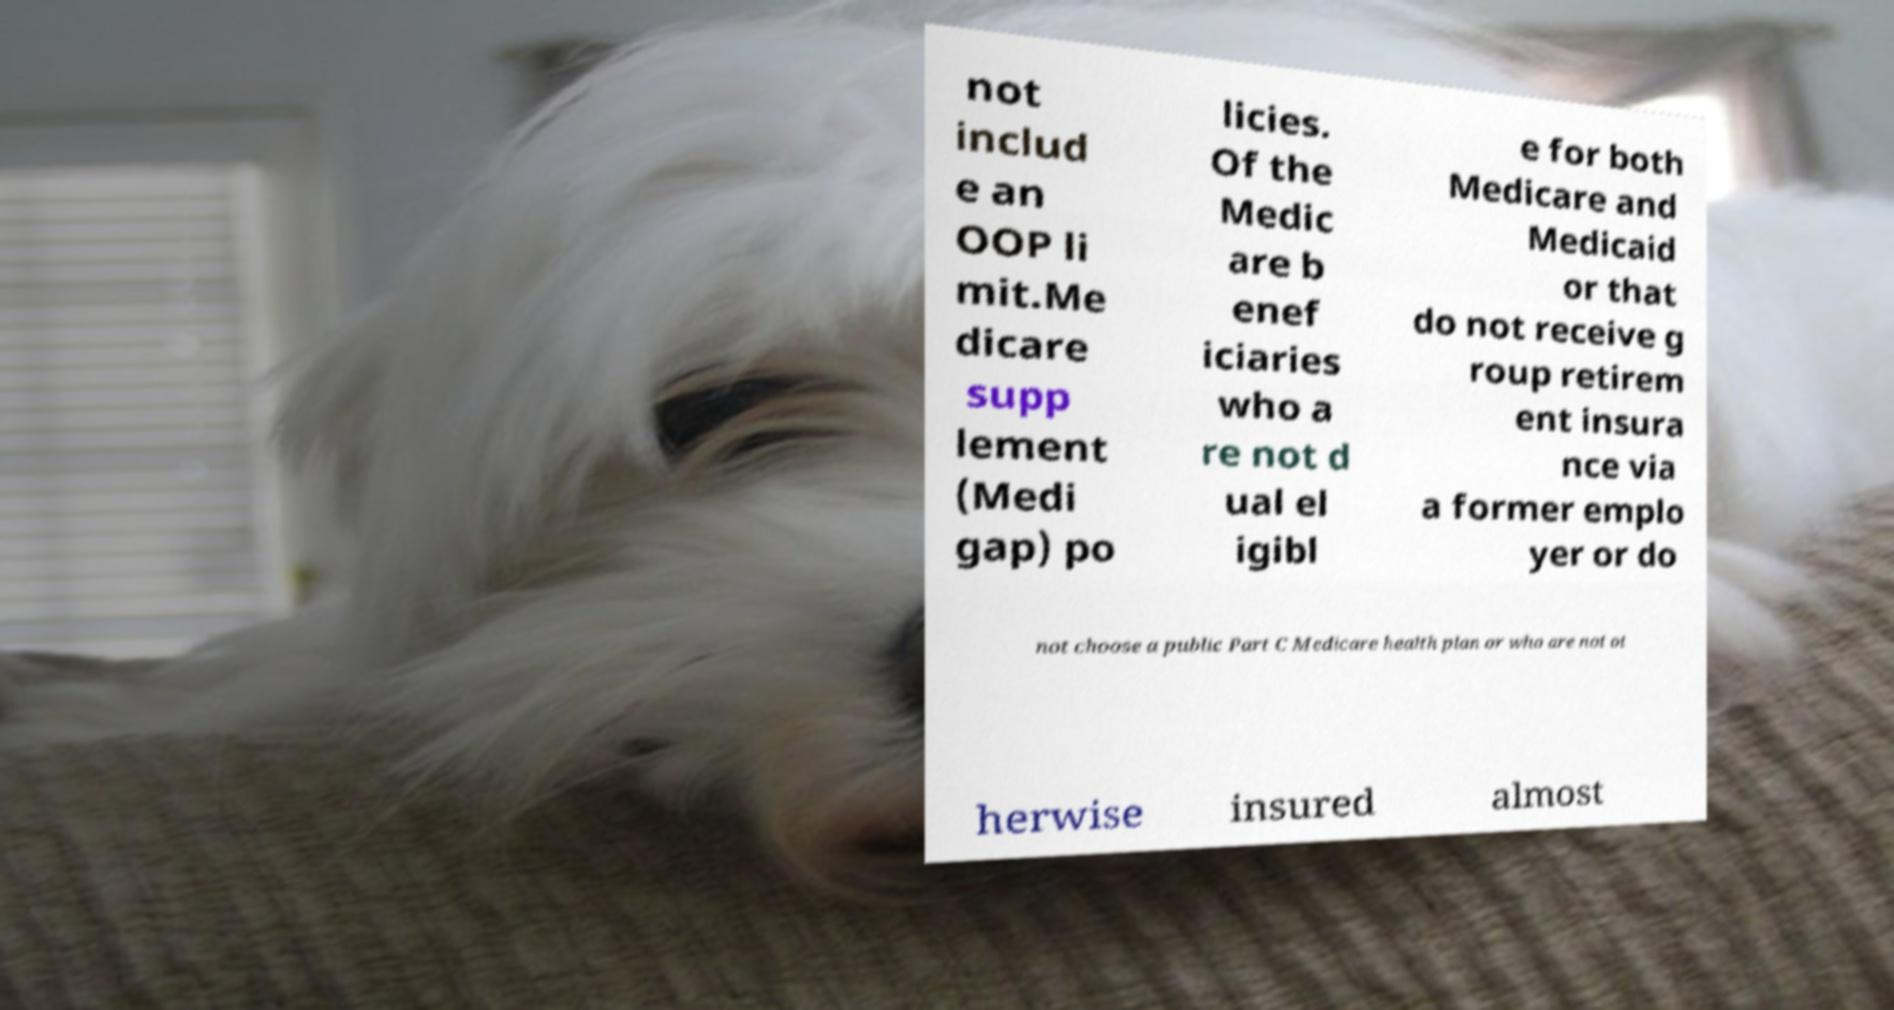Can you accurately transcribe the text from the provided image for me? not includ e an OOP li mit.Me dicare supp lement (Medi gap) po licies. Of the Medic are b enef iciaries who a re not d ual el igibl e for both Medicare and Medicaid or that do not receive g roup retirem ent insura nce via a former emplo yer or do not choose a public Part C Medicare health plan or who are not ot herwise insured almost 